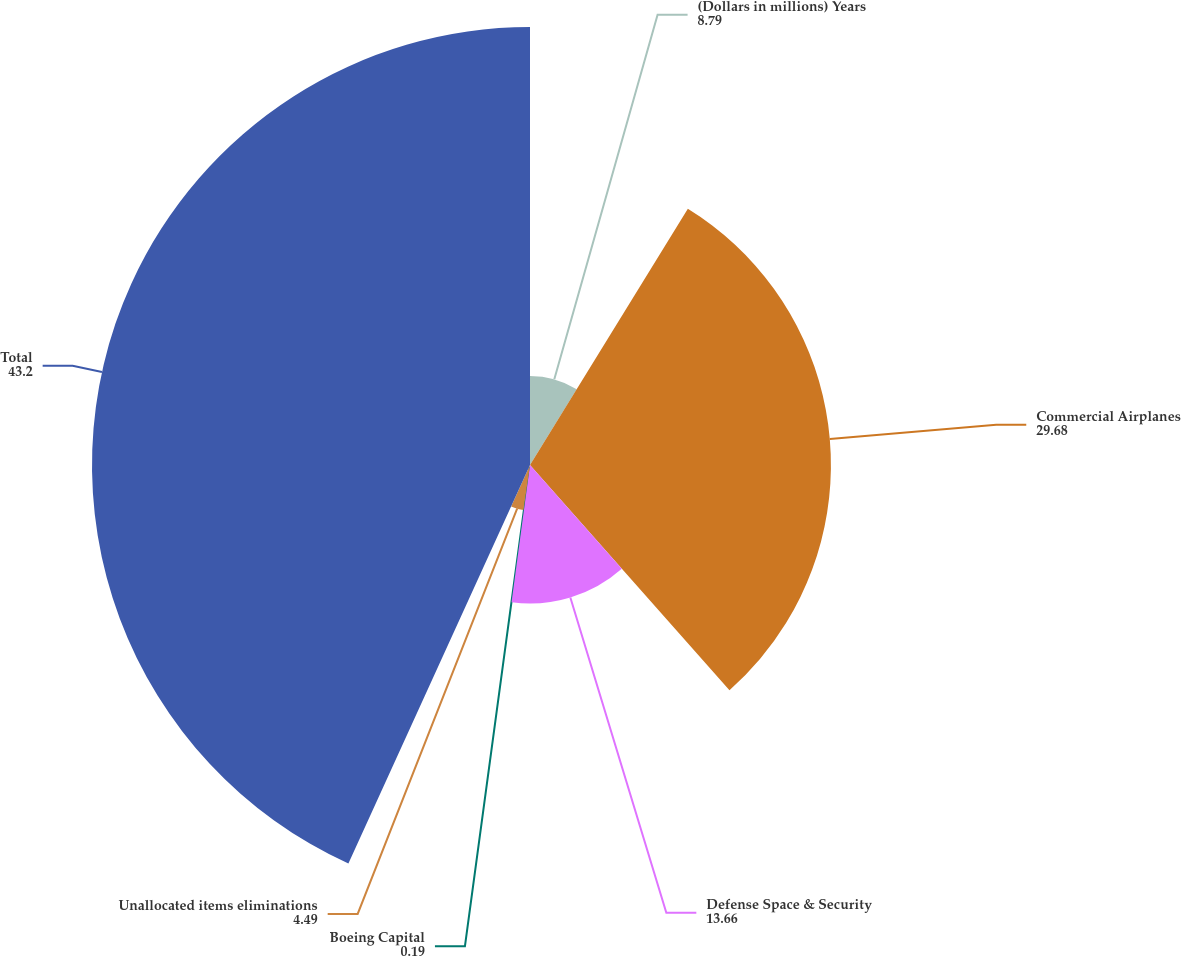Convert chart. <chart><loc_0><loc_0><loc_500><loc_500><pie_chart><fcel>(Dollars in millions) Years<fcel>Commercial Airplanes<fcel>Defense Space & Security<fcel>Boeing Capital<fcel>Unallocated items eliminations<fcel>Total<nl><fcel>8.79%<fcel>29.68%<fcel>13.66%<fcel>0.19%<fcel>4.49%<fcel>43.2%<nl></chart> 